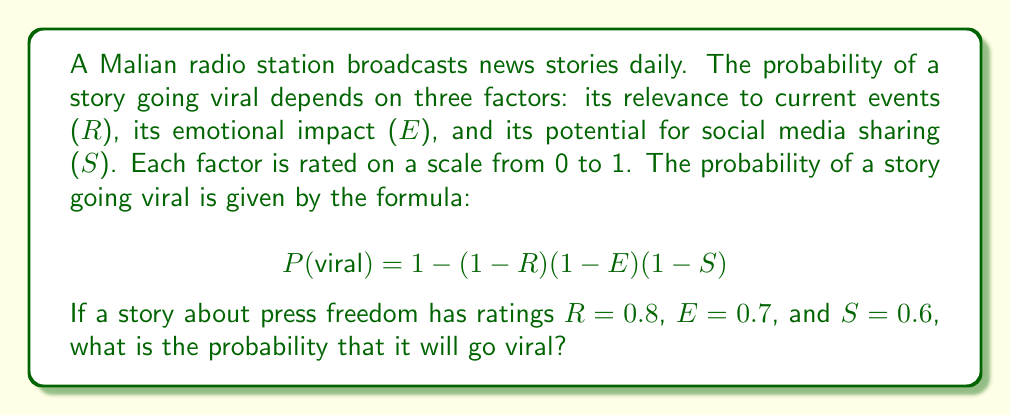Solve this math problem. To solve this problem, we'll follow these steps:

1) We are given the formula for the probability of a story going viral:
   $$P(\text{viral}) = 1 - (1-R)(1-E)(1-S)$$

2) We are also given the ratings for each factor:
   $R = 0.8$ (relevance to current events)
   $E = 0.7$ (emotional impact)
   $S = 0.6$ (potential for social media sharing)

3) Let's substitute these values into the formula:
   $$P(\text{viral}) = 1 - (1-0.8)(1-0.7)(1-0.6)$$

4) Now, let's calculate each part inside the parentheses:
   $(1-0.8) = 0.2$
   $(1-0.7) = 0.3$
   $(1-0.6) = 0.4$

5) Multiply these values:
   $$P(\text{viral}) = 1 - (0.2 \times 0.3 \times 0.4)$$
   $$P(\text{viral}) = 1 - 0.024$$

6) Perform the final subtraction:
   $$P(\text{viral}) = 0.976$$

Therefore, the probability that the story about press freedom will go viral is 0.976 or 97.6%.
Answer: 0.976 